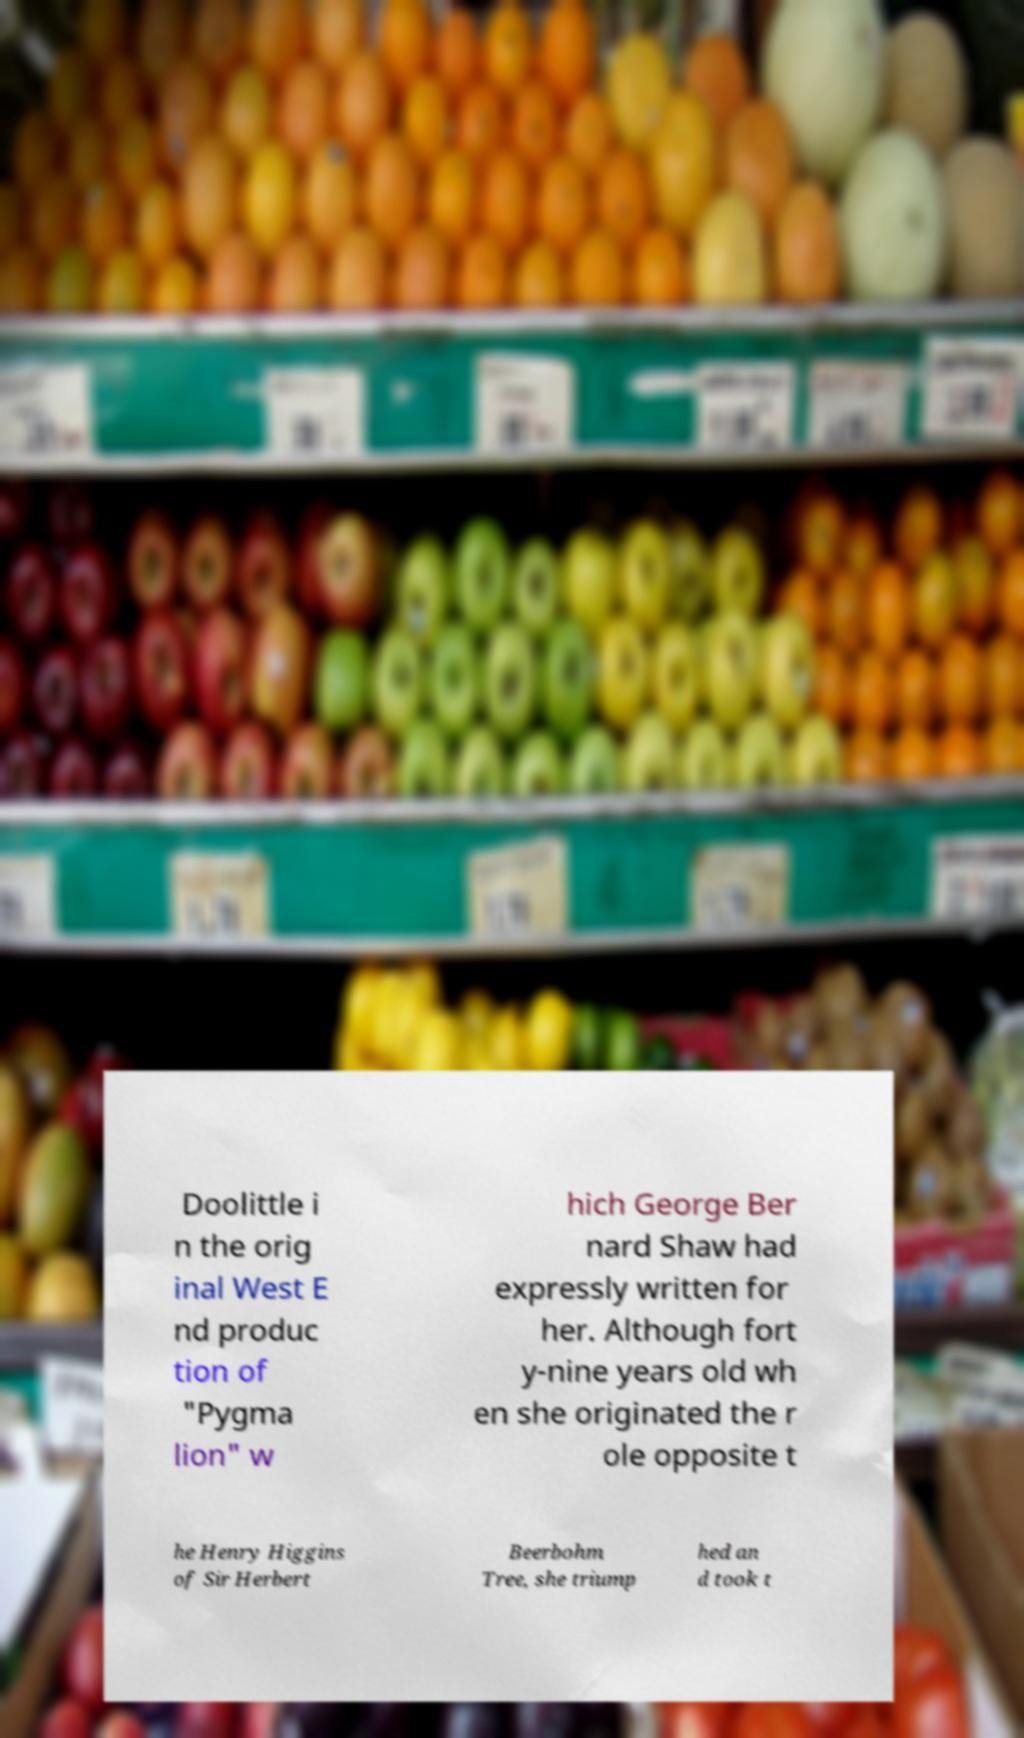There's text embedded in this image that I need extracted. Can you transcribe it verbatim? Doolittle i n the orig inal West E nd produc tion of "Pygma lion" w hich George Ber nard Shaw had expressly written for her. Although fort y-nine years old wh en she originated the r ole opposite t he Henry Higgins of Sir Herbert Beerbohm Tree, she triump hed an d took t 